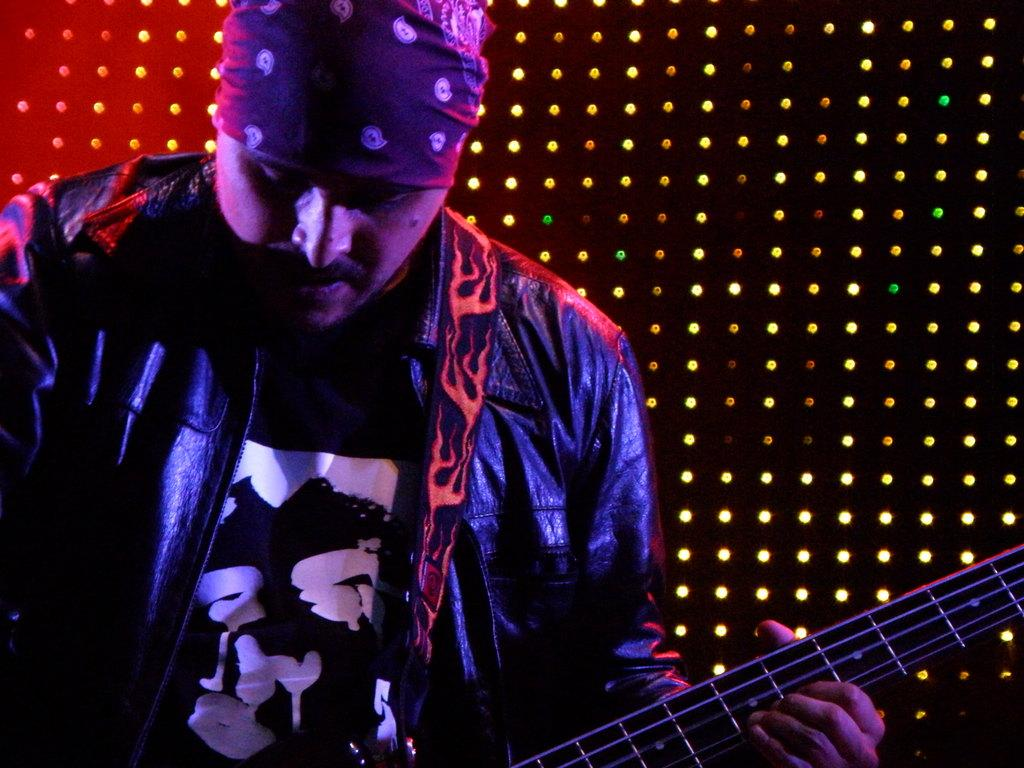Who is the main subject in the image? There is a man in the image. What is the man wearing? The man is wearing a leather black jacket. What is the man holding in the image? The man is holding a guitar. Can you describe the background of the image? The background of the image is black with lights. What type of shoes is the man wearing in the image? The provided facts do not mention any shoes, so we cannot determine the type of shoes the man is wearing. 